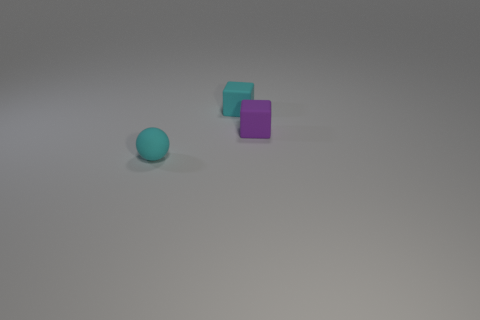There is a object that is the same color as the tiny ball; what is its shape?
Your response must be concise. Cube. Are there fewer small cyan matte balls in front of the tiny cyan rubber sphere than tiny cyan matte things?
Keep it short and to the point. Yes. What is the block that is in front of the small cyan cube made of?
Make the answer very short. Rubber. What number of other things are the same size as the cyan matte cube?
Give a very brief answer. 2. There is a purple block; is it the same size as the cyan thing in front of the tiny purple matte cube?
Make the answer very short. Yes. The tiny thing that is right of the cyan thing behind the small cyan rubber object that is in front of the small cyan matte block is what shape?
Provide a short and direct response. Cube. Are there fewer cyan rubber things than small purple rubber objects?
Keep it short and to the point. No. Are there any tiny blocks on the right side of the small cyan rubber cube?
Your response must be concise. Yes. What is the shape of the matte object that is both to the right of the rubber ball and on the left side of the purple thing?
Provide a short and direct response. Cube. Is there another purple object of the same shape as the purple rubber object?
Give a very brief answer. No. 